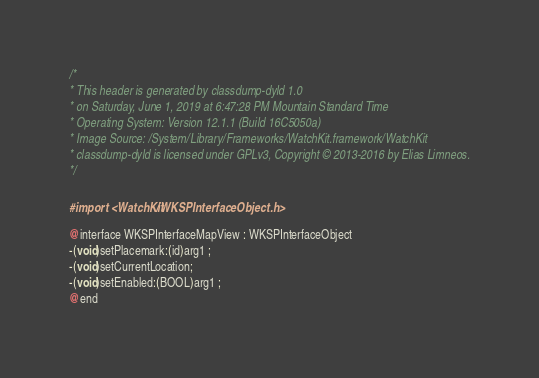<code> <loc_0><loc_0><loc_500><loc_500><_C_>/*
* This header is generated by classdump-dyld 1.0
* on Saturday, June 1, 2019 at 6:47:28 PM Mountain Standard Time
* Operating System: Version 12.1.1 (Build 16C5050a)
* Image Source: /System/Library/Frameworks/WatchKit.framework/WatchKit
* classdump-dyld is licensed under GPLv3, Copyright © 2013-2016 by Elias Limneos.
*/

#import <WatchKit/WKSPInterfaceObject.h>

@interface WKSPInterfaceMapView : WKSPInterfaceObject
-(void)setPlacemark:(id)arg1 ;
-(void)setCurrentLocation;
-(void)setEnabled:(BOOL)arg1 ;
@end

</code> 